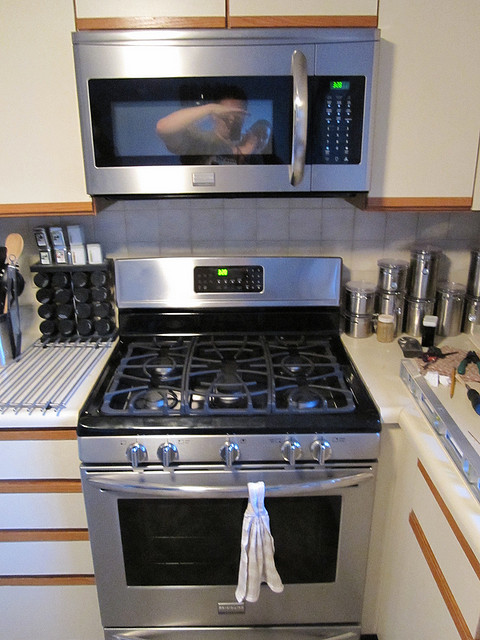Is there anything unique about the way the kitchen towel is hung? The kitchen towel is draped through the oven's door handle in a simple yet tidy fashion, which is quite common in many kitchens. 